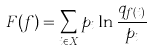Convert formula to latex. <formula><loc_0><loc_0><loc_500><loc_500>F ( f ) = \sum _ { i \in X } p _ { i } \ln \frac { q _ { f ( i ) } } { p _ { i } }</formula> 